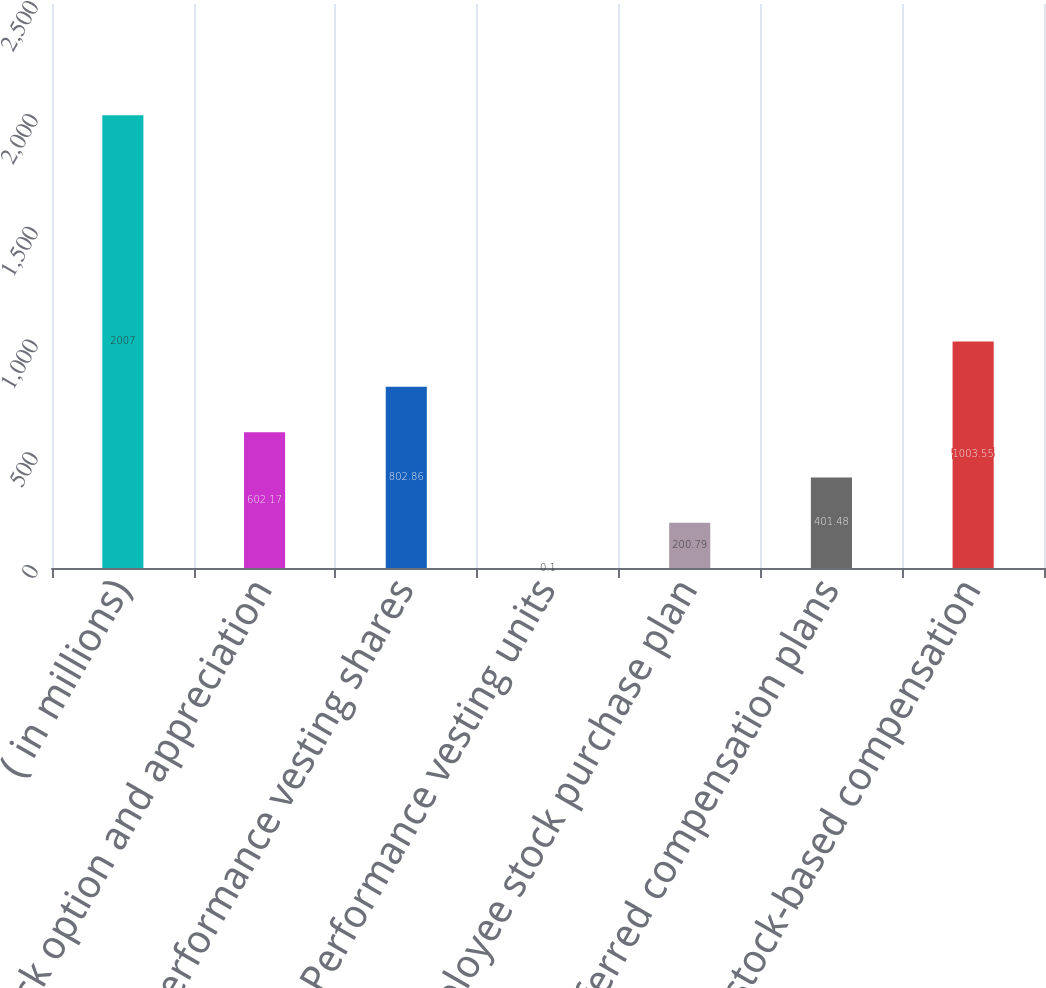Convert chart to OTSL. <chart><loc_0><loc_0><loc_500><loc_500><bar_chart><fcel>( in millions)<fcel>Stock option and appreciation<fcel>Performance vesting shares<fcel>Performance vesting units<fcel>Employee stock purchase plan<fcel>Deferred compensation plans<fcel>Total stock-based compensation<nl><fcel>2007<fcel>602.17<fcel>802.86<fcel>0.1<fcel>200.79<fcel>401.48<fcel>1003.55<nl></chart> 